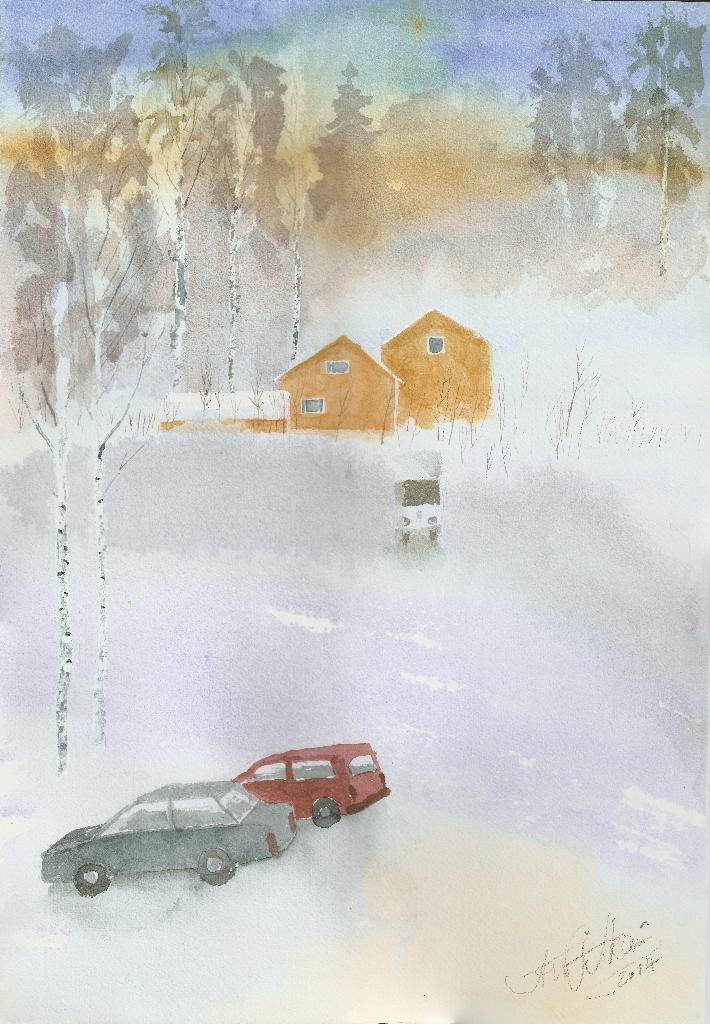Please provide a concise description of this image. In this image I can see there is a painting and there are cars, houses and trees. 